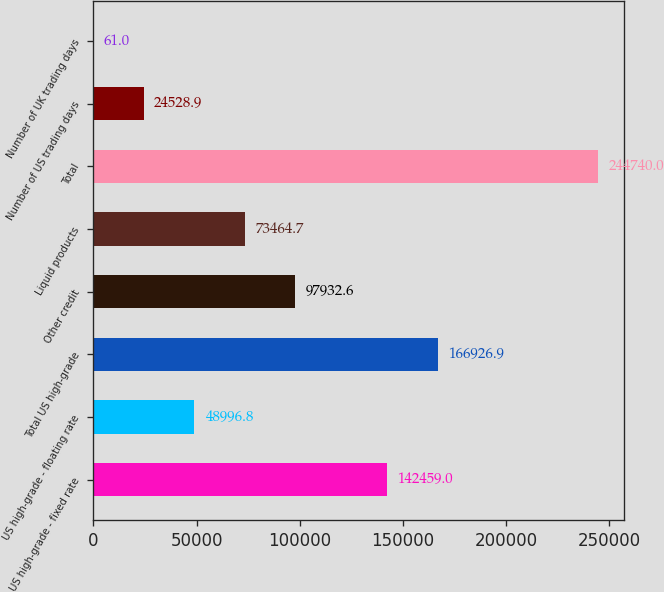Convert chart to OTSL. <chart><loc_0><loc_0><loc_500><loc_500><bar_chart><fcel>US high-grade - fixed rate<fcel>US high-grade - floating rate<fcel>Total US high-grade<fcel>Other credit<fcel>Liquid products<fcel>Total<fcel>Number of US trading days<fcel>Number of UK trading days<nl><fcel>142459<fcel>48996.8<fcel>166927<fcel>97932.6<fcel>73464.7<fcel>244740<fcel>24528.9<fcel>61<nl></chart> 